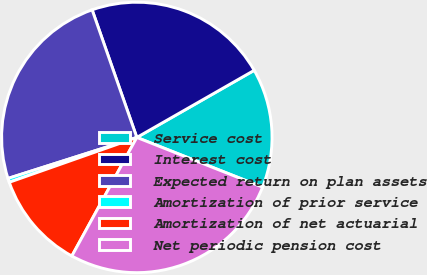<chart> <loc_0><loc_0><loc_500><loc_500><pie_chart><fcel>Service cost<fcel>Interest cost<fcel>Expected return on plan assets<fcel>Amortization of prior service<fcel>Amortization of net actuarial<fcel>Net periodic pension cost<nl><fcel>14.26%<fcel>22.1%<fcel>24.54%<fcel>0.48%<fcel>11.64%<fcel>26.99%<nl></chart> 